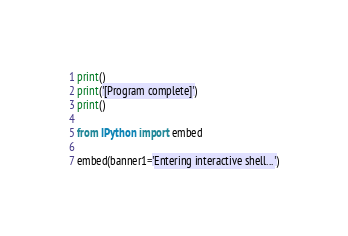Convert code to text. <code><loc_0><loc_0><loc_500><loc_500><_Python_>print()
print('[Program complete]')
print()

from IPython import embed

embed(banner1='Entering interactive shell...')
</code> 